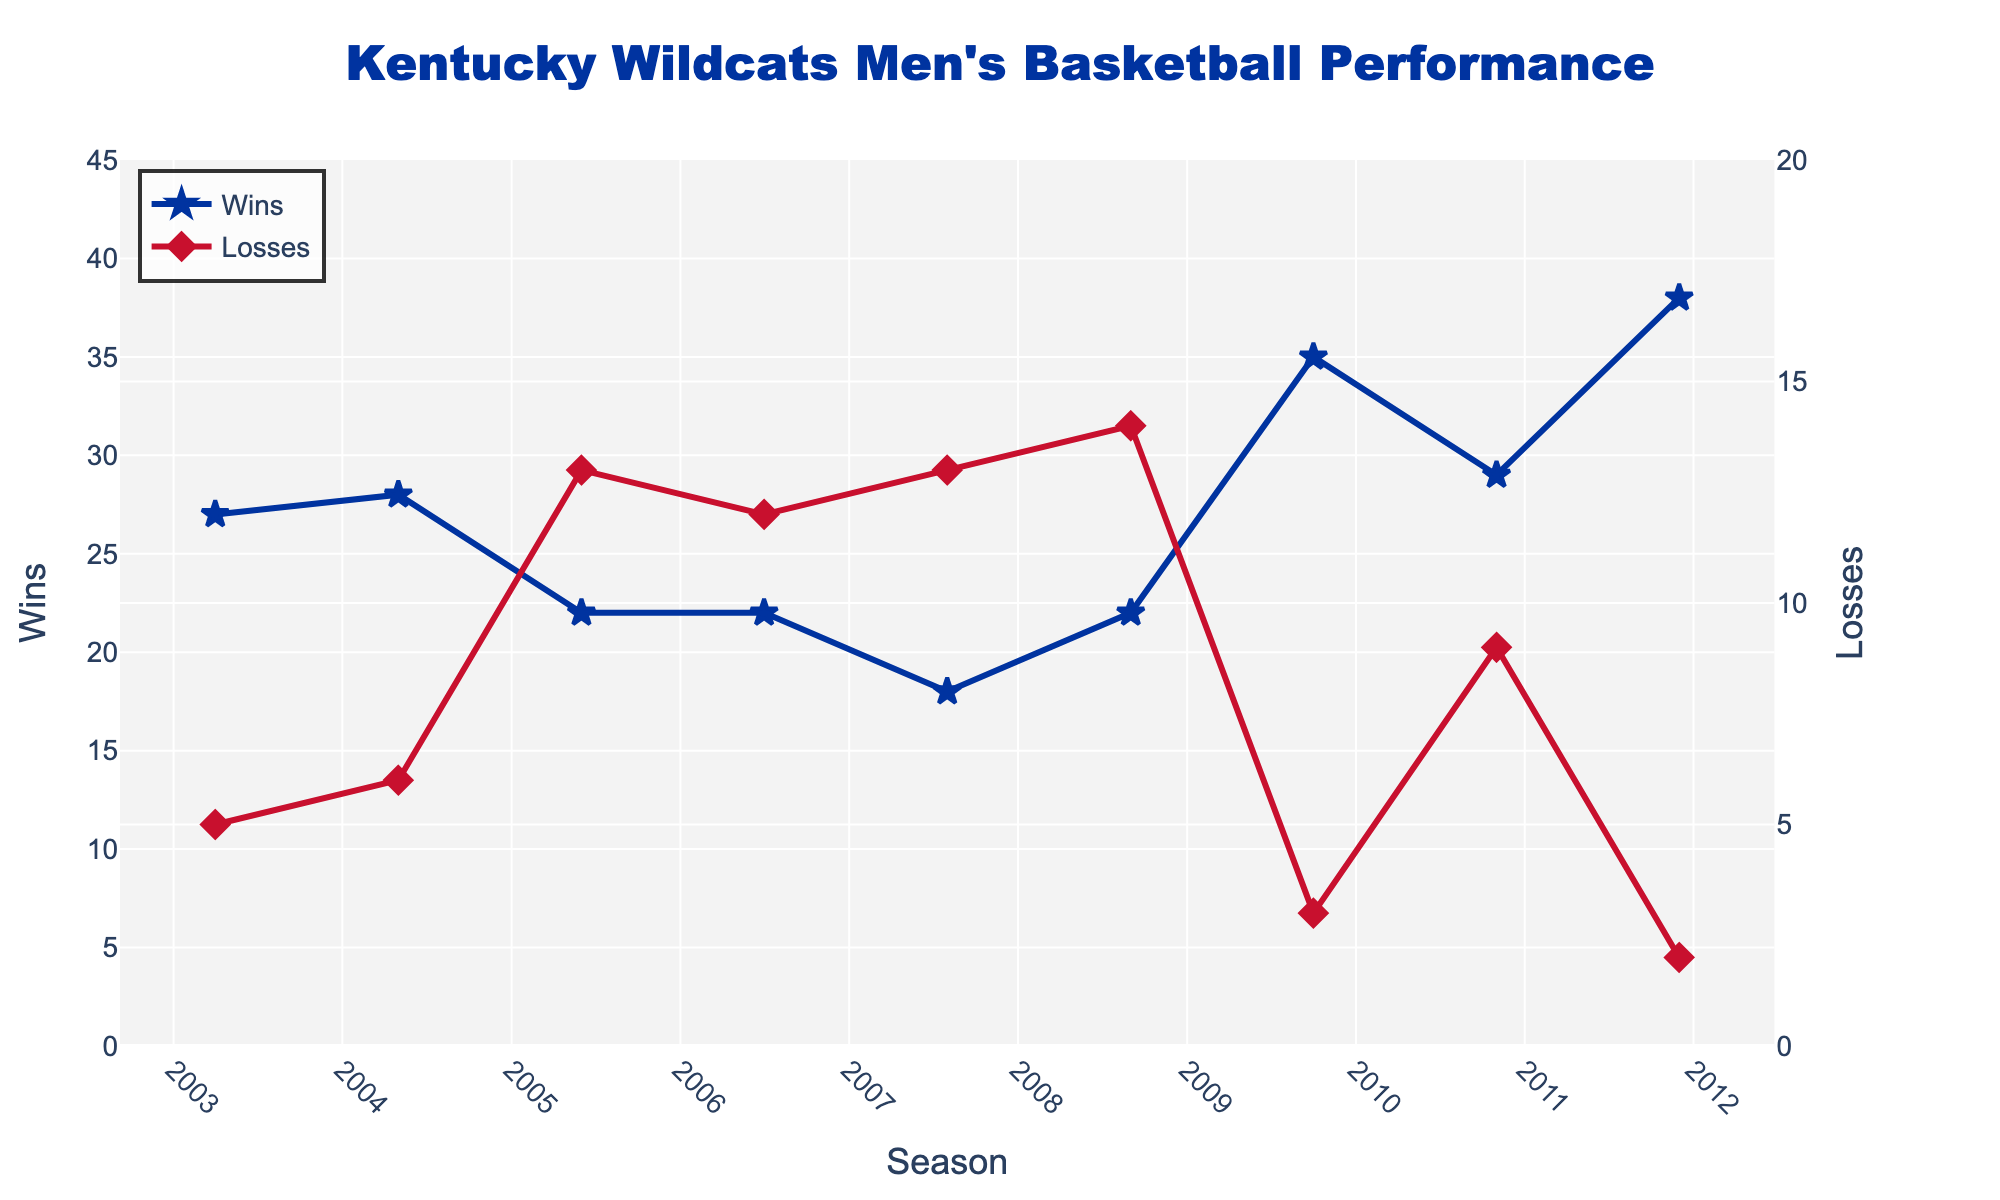What season had the highest number of wins? The tallest blue line segment represents the highest number of wins. The season where Kentucky Wildcats had 38 wins is both 2011-12 and 2014-15.
Answer: 2011-12 and 2014-15 In which season did Kentucky Wildcats have the most losses? The tallest red line segment indicates the highest number of losses, which is 16 in the 2020-21 season.
Answer: 2020-21 What is the difference between the number of wins and losses in the 2009-10 season? From the chart, in the 2009-10 season, wins are 35, and losses are 3. The difference is calculated as 35 - 3.
Answer: 32 How many seasons had more than 30 wins? By counting the number of blue line segments above the 30 wins mark, there are four such seasons: 2009-10, 2011-12, 2014-15, and 2016-17.
Answer: 4 Which seasons had the same number of wins? By identifying seasons with equal heights of blue line segments, 2006-07 and 2005-06 both have 22 wins, and 2019-20 and 2015-16 both have 27 wins.
Answer: 2006-07 and 2005-06; 2019-20 and 2015-16 What was the trend in the number of losses between the 2019-20 and 2020-21 seasons? Observing the red line segments, a rise from 6 losses in 2019-20 to 16 losses in 2020-21 indicates an upward trend.
Answer: Increased Comparing the 2011-12 and 2012-13 seasons, what is the change in the win-loss record? In 2011-12, there were 38 wins and 2 losses. In 2012-13, it was 21 wins and 12 losses. The change in wins is 38 - 21 = 17 fewer wins, and the change in losses is 12 - 2 = 10 more losses.
Answer: 17 fewer wins and 10 more losses What is the average number of wins over the past 20 seasons? Sum the wins over all seasons (27 + 28 + 22 + 22 + 18 + 22 + 35 + 29 + 38 + 21 + 29 + 38 + 27 + 32 + 26 + 30 + 25 + 9 + 26 + 22 = 533) and divide by the number of seasons, 20. So, 533/20 = 26.65 wins on average.
Answer: 26.65 What can be inferred about the team's performance trend after the 2014-15 season? Observing the figure, after peaking with 38 wins in 2014-15, the number of wins decreased, followed by fluctuations, indicating inconsistency or a downward trend. The subsequent seasons did not reach the 38-win mark.
Answer: Inconsistent downward trend In which seasons did the Kentucky Wildcats achieve less than 20 wins? By identifying the blue line segments below the 20-win mark, we find only the 2007-08 and 2020-21 seasons had fewer than 20 wins.
Answer: 2007-08 and 2020-21 